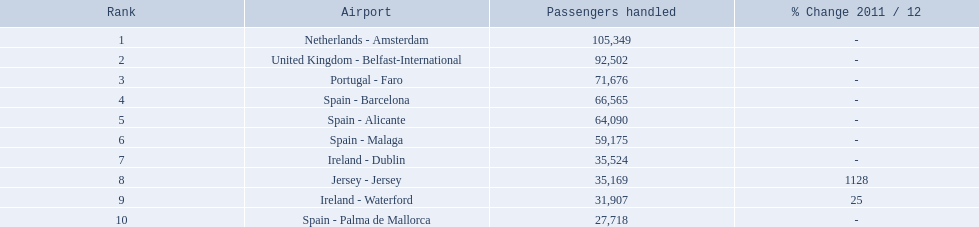Which airports are in europe? Netherlands - Amsterdam, United Kingdom - Belfast-International, Portugal - Faro, Spain - Barcelona, Spain - Alicante, Spain - Malaga, Ireland - Dublin, Ireland - Waterford, Spain - Palma de Mallorca. Which one is from portugal? Portugal - Faro. What are all the itineraries originating from london southend airport? Netherlands - Amsterdam, United Kingdom - Belfast-International, Portugal - Faro, Spain - Barcelona, Spain - Alicante, Spain - Malaga, Ireland - Dublin, Jersey - Jersey, Ireland - Waterford, Spain - Palma de Mallorca. How many passengers have visited each destination? 105,349, 92,502, 71,676, 66,565, 64,090, 59,175, 35,524, 35,169, 31,907, 27,718. And which destination has been the most attractive to passengers? Netherlands - Amsterdam. What are all the airports in the top 10 most active routes to and from london southend airport? Netherlands - Amsterdam, United Kingdom - Belfast-International, Portugal - Faro, Spain - Barcelona, Spain - Alicante, Spain - Malaga, Ireland - Dublin, Jersey - Jersey, Ireland - Waterford, Spain - Palma de Mallorca. Which airports are in portugal? Portugal - Faro. 